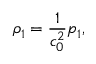<formula> <loc_0><loc_0><loc_500><loc_500>\rho _ { 1 } = \frac { 1 } { c _ { 0 } ^ { 2 } } p _ { 1 } ,</formula> 